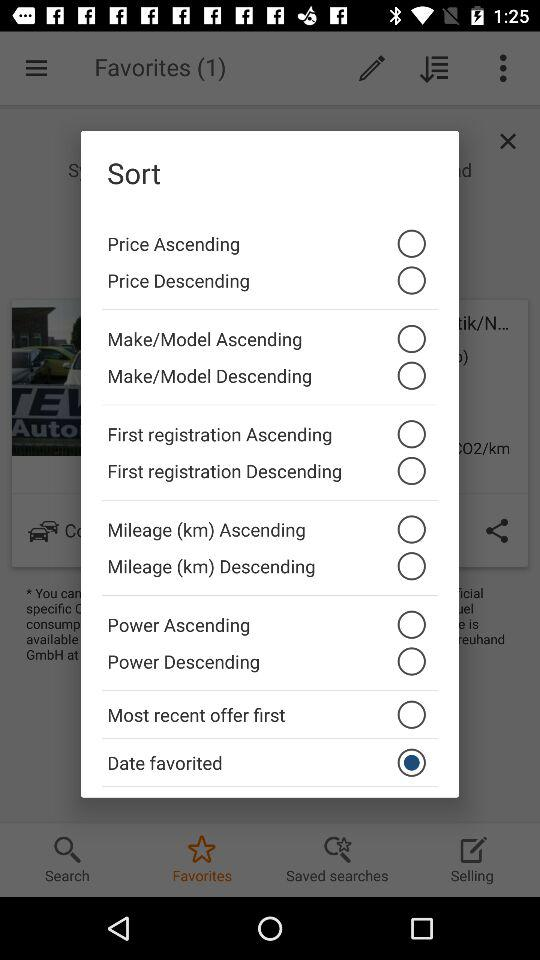What is the unit of mileage? The unit of mileage is km. 